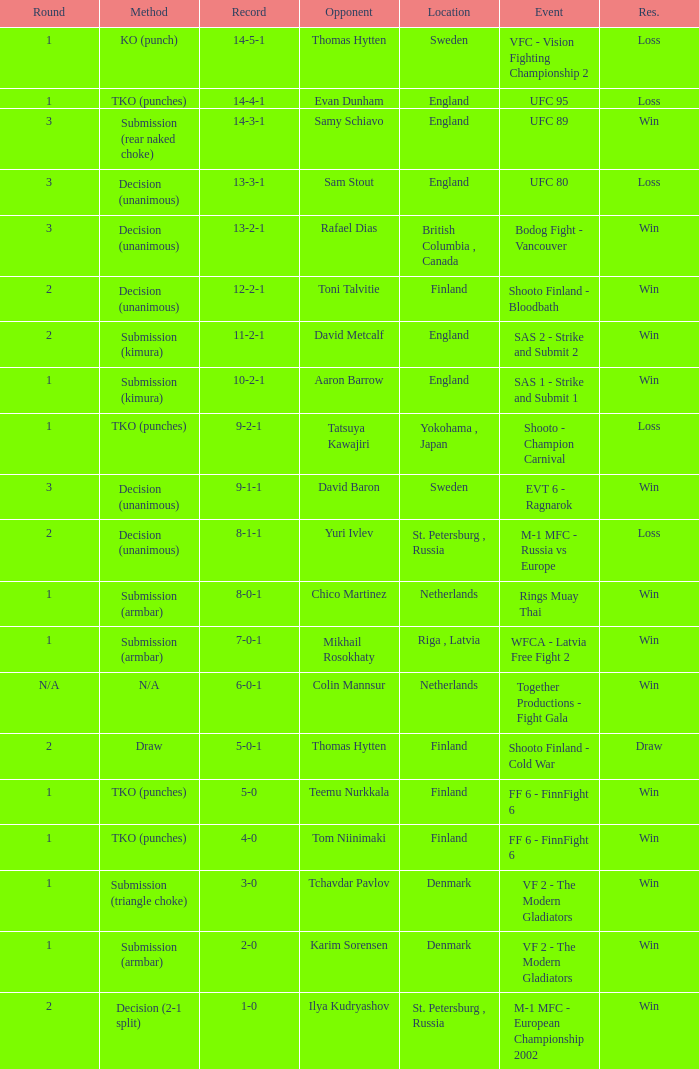Who was the opponent with a record of 14-4-1 and has a round of 1? Evan Dunham. 